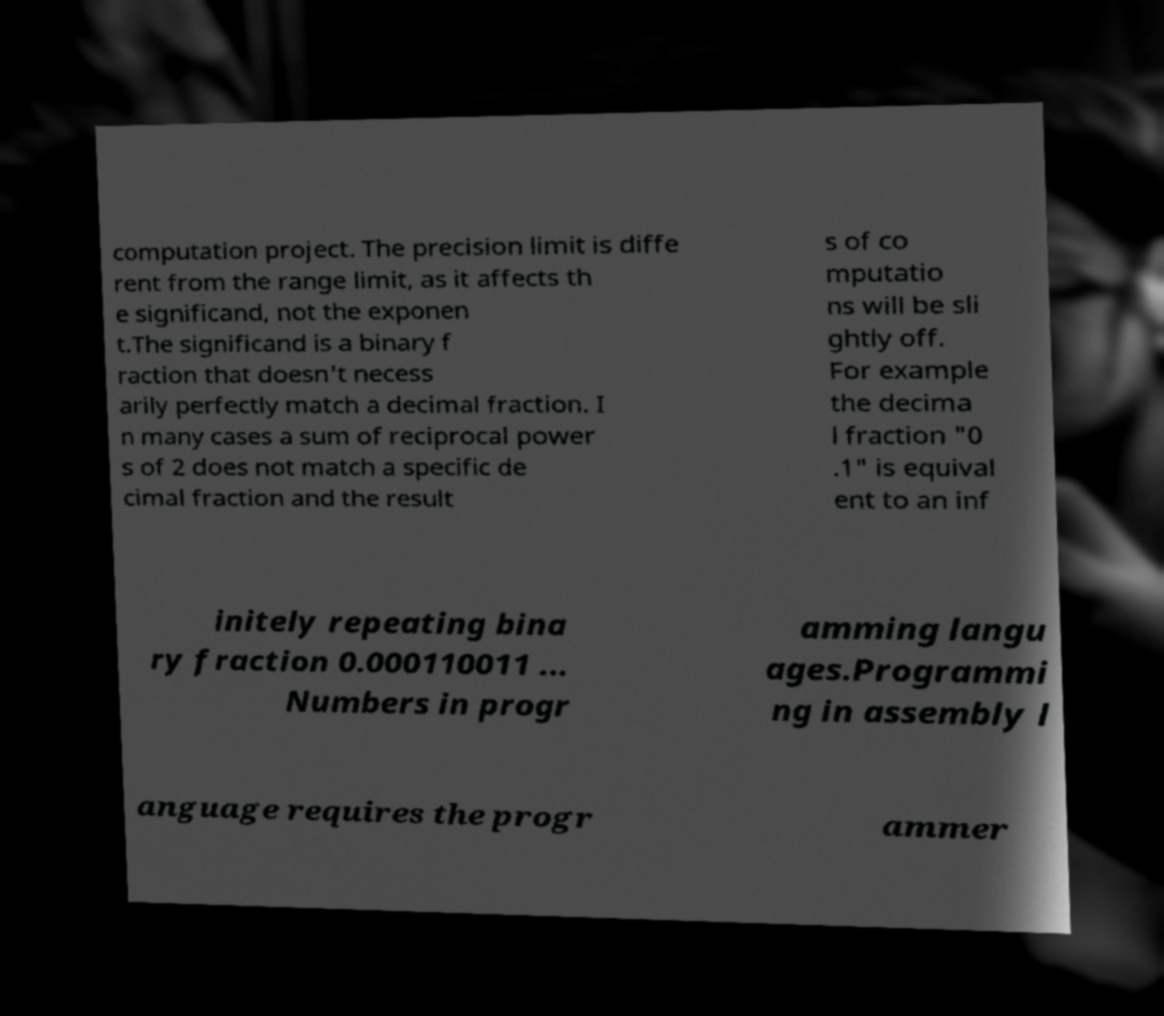Could you assist in decoding the text presented in this image and type it out clearly? computation project. The precision limit is diffe rent from the range limit, as it affects th e significand, not the exponen t.The significand is a binary f raction that doesn't necess arily perfectly match a decimal fraction. I n many cases a sum of reciprocal power s of 2 does not match a specific de cimal fraction and the result s of co mputatio ns will be sli ghtly off. For example the decima l fraction "0 .1" is equival ent to an inf initely repeating bina ry fraction 0.000110011 ... Numbers in progr amming langu ages.Programmi ng in assembly l anguage requires the progr ammer 